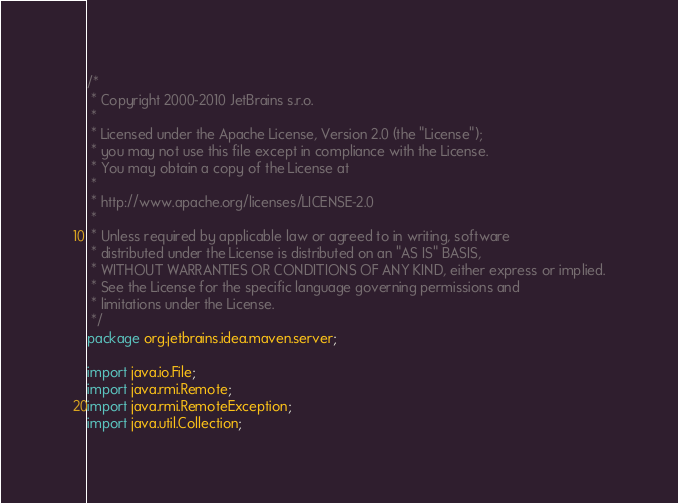<code> <loc_0><loc_0><loc_500><loc_500><_Java_>/*
 * Copyright 2000-2010 JetBrains s.r.o.
 *
 * Licensed under the Apache License, Version 2.0 (the "License");
 * you may not use this file except in compliance with the License.
 * You may obtain a copy of the License at
 *
 * http://www.apache.org/licenses/LICENSE-2.0
 *
 * Unless required by applicable law or agreed to in writing, software
 * distributed under the License is distributed on an "AS IS" BASIS,
 * WITHOUT WARRANTIES OR CONDITIONS OF ANY KIND, either express or implied.
 * See the License for the specific language governing permissions and
 * limitations under the License.
 */
package org.jetbrains.idea.maven.server;

import java.io.File;
import java.rmi.Remote;
import java.rmi.RemoteException;
import java.util.Collection;
</code> 